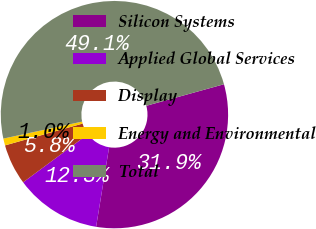Convert chart. <chart><loc_0><loc_0><loc_500><loc_500><pie_chart><fcel>Silicon Systems<fcel>Applied Global Services<fcel>Display<fcel>Energy and Environmental<fcel>Total<nl><fcel>31.89%<fcel>12.27%<fcel>5.79%<fcel>0.98%<fcel>49.07%<nl></chart> 